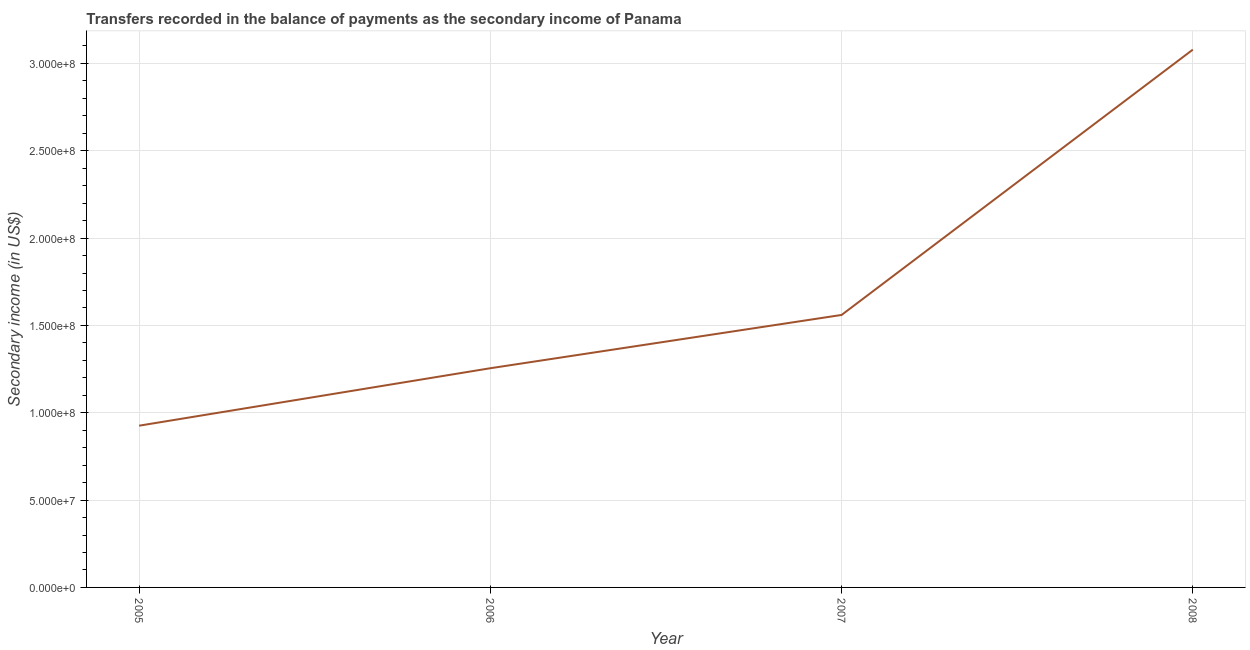What is the amount of secondary income in 2007?
Provide a succinct answer. 1.56e+08. Across all years, what is the maximum amount of secondary income?
Ensure brevity in your answer.  3.08e+08. Across all years, what is the minimum amount of secondary income?
Ensure brevity in your answer.  9.26e+07. In which year was the amount of secondary income maximum?
Your answer should be very brief. 2008. What is the sum of the amount of secondary income?
Offer a terse response. 6.82e+08. What is the difference between the amount of secondary income in 2005 and 2007?
Give a very brief answer. -6.34e+07. What is the average amount of secondary income per year?
Provide a succinct answer. 1.70e+08. What is the median amount of secondary income?
Your answer should be very brief. 1.41e+08. In how many years, is the amount of secondary income greater than 270000000 US$?
Your answer should be very brief. 1. Do a majority of the years between 2005 and 2008 (inclusive) have amount of secondary income greater than 290000000 US$?
Provide a succinct answer. No. What is the ratio of the amount of secondary income in 2005 to that in 2007?
Provide a succinct answer. 0.59. Is the amount of secondary income in 2007 less than that in 2008?
Make the answer very short. Yes. What is the difference between the highest and the second highest amount of secondary income?
Provide a short and direct response. 1.52e+08. Is the sum of the amount of secondary income in 2006 and 2008 greater than the maximum amount of secondary income across all years?
Make the answer very short. Yes. What is the difference between the highest and the lowest amount of secondary income?
Offer a terse response. 2.15e+08. Does the amount of secondary income monotonically increase over the years?
Ensure brevity in your answer.  Yes. How many lines are there?
Keep it short and to the point. 1. Are the values on the major ticks of Y-axis written in scientific E-notation?
Keep it short and to the point. Yes. Does the graph contain any zero values?
Your response must be concise. No. Does the graph contain grids?
Offer a terse response. Yes. What is the title of the graph?
Offer a very short reply. Transfers recorded in the balance of payments as the secondary income of Panama. What is the label or title of the Y-axis?
Give a very brief answer. Secondary income (in US$). What is the Secondary income (in US$) of 2005?
Offer a very short reply. 9.26e+07. What is the Secondary income (in US$) of 2006?
Your response must be concise. 1.26e+08. What is the Secondary income (in US$) in 2007?
Keep it short and to the point. 1.56e+08. What is the Secondary income (in US$) of 2008?
Your answer should be compact. 3.08e+08. What is the difference between the Secondary income (in US$) in 2005 and 2006?
Provide a short and direct response. -3.29e+07. What is the difference between the Secondary income (in US$) in 2005 and 2007?
Provide a short and direct response. -6.34e+07. What is the difference between the Secondary income (in US$) in 2005 and 2008?
Your answer should be very brief. -2.15e+08. What is the difference between the Secondary income (in US$) in 2006 and 2007?
Provide a succinct answer. -3.05e+07. What is the difference between the Secondary income (in US$) in 2006 and 2008?
Give a very brief answer. -1.82e+08. What is the difference between the Secondary income (in US$) in 2007 and 2008?
Keep it short and to the point. -1.52e+08. What is the ratio of the Secondary income (in US$) in 2005 to that in 2006?
Your answer should be compact. 0.74. What is the ratio of the Secondary income (in US$) in 2005 to that in 2007?
Your response must be concise. 0.59. What is the ratio of the Secondary income (in US$) in 2005 to that in 2008?
Provide a short and direct response. 0.3. What is the ratio of the Secondary income (in US$) in 2006 to that in 2007?
Offer a terse response. 0.8. What is the ratio of the Secondary income (in US$) in 2006 to that in 2008?
Give a very brief answer. 0.41. What is the ratio of the Secondary income (in US$) in 2007 to that in 2008?
Ensure brevity in your answer.  0.51. 